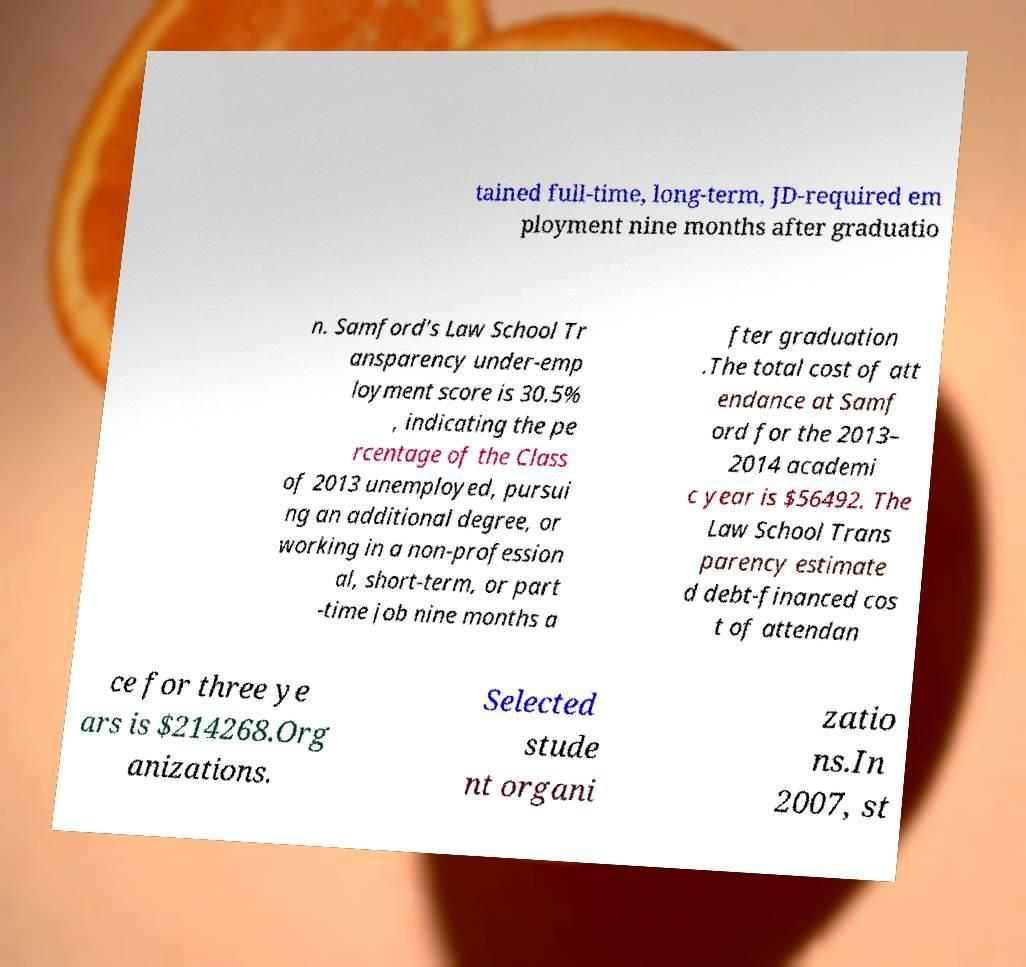There's text embedded in this image that I need extracted. Can you transcribe it verbatim? tained full-time, long-term, JD-required em ployment nine months after graduatio n. Samford's Law School Tr ansparency under-emp loyment score is 30.5% , indicating the pe rcentage of the Class of 2013 unemployed, pursui ng an additional degree, or working in a non-profession al, short-term, or part -time job nine months a fter graduation .The total cost of att endance at Samf ord for the 2013– 2014 academi c year is $56492. The Law School Trans parency estimate d debt-financed cos t of attendan ce for three ye ars is $214268.Org anizations. Selected stude nt organi zatio ns.In 2007, st 